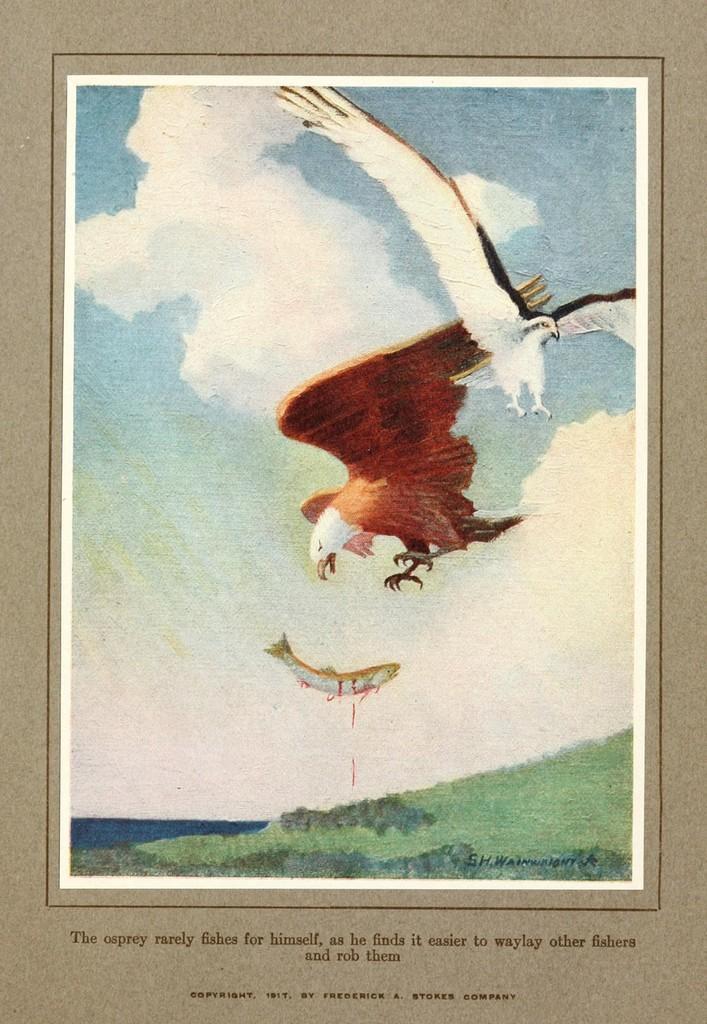Please provide a concise description of this image. In this image I see a picture on which there are 2 birds and a fish over here and I see the land and I see the sky and I see the watermark over here and I see something is written over here. 